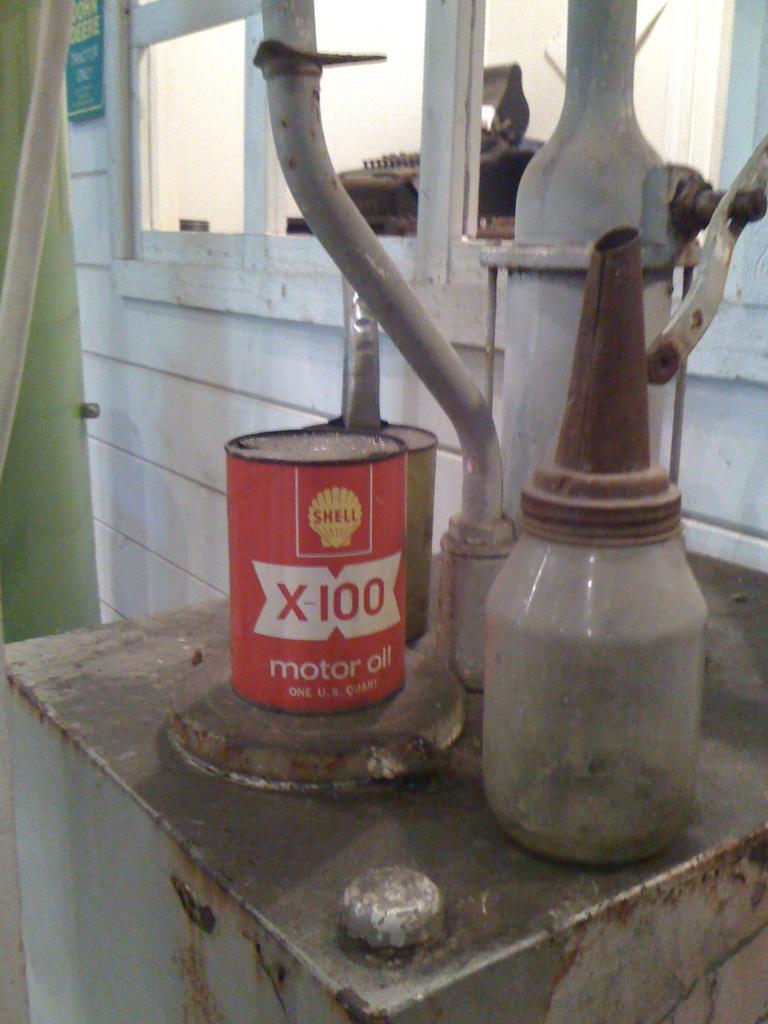What is the number on the can?
Offer a terse response. 100. 